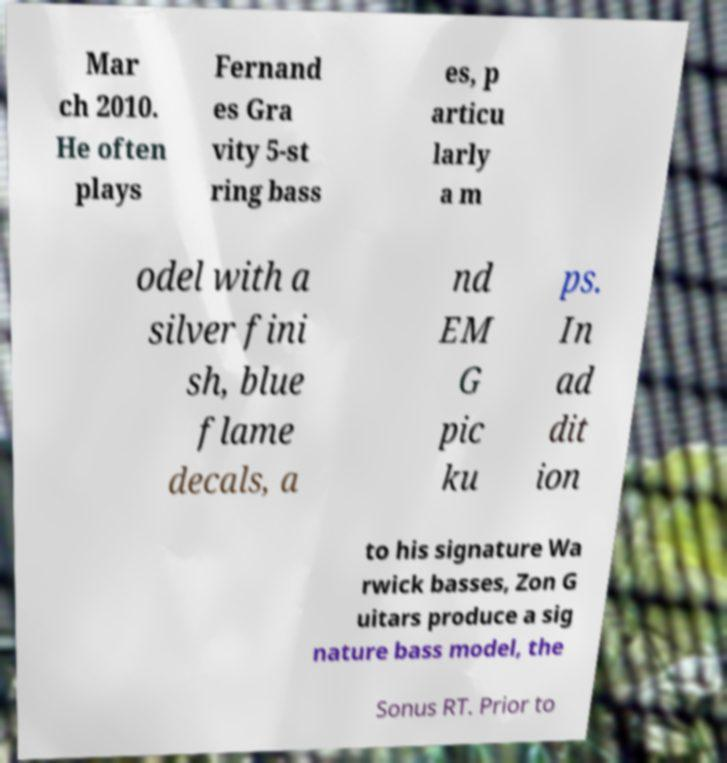Please identify and transcribe the text found in this image. Mar ch 2010. He often plays Fernand es Gra vity 5-st ring bass es, p articu larly a m odel with a silver fini sh, blue flame decals, a nd EM G pic ku ps. In ad dit ion to his signature Wa rwick basses, Zon G uitars produce a sig nature bass model, the Sonus RT. Prior to 